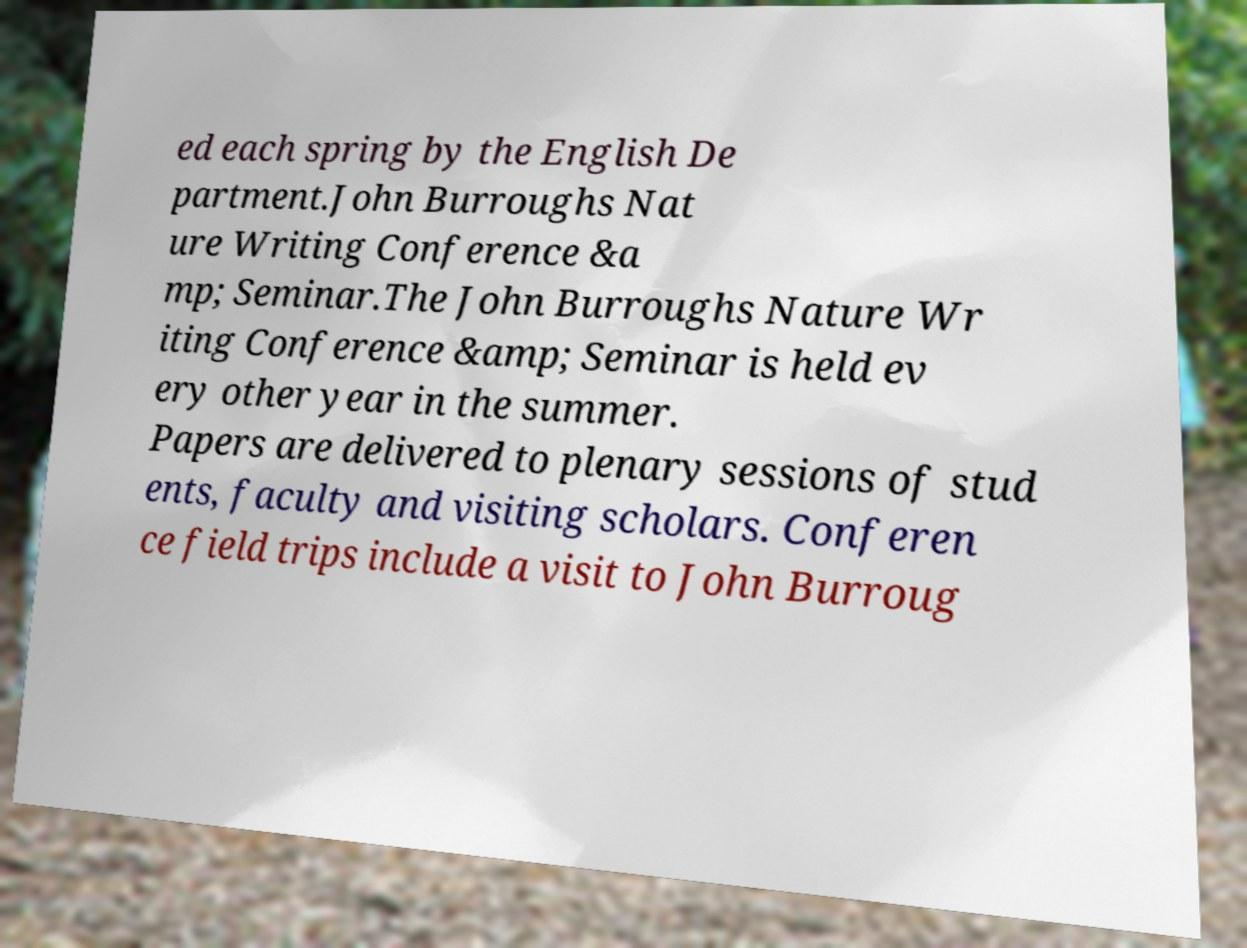Please identify and transcribe the text found in this image. ed each spring by the English De partment.John Burroughs Nat ure Writing Conference &a mp; Seminar.The John Burroughs Nature Wr iting Conference &amp; Seminar is held ev ery other year in the summer. Papers are delivered to plenary sessions of stud ents, faculty and visiting scholars. Conferen ce field trips include a visit to John Burroug 